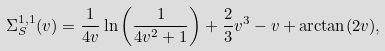Convert formula to latex. <formula><loc_0><loc_0><loc_500><loc_500>\Sigma _ { S } ^ { 1 , 1 } ( v ) = \frac { 1 } { 4 v } \ln \left ( \frac { 1 } { 4 v ^ { 2 } + 1 } \right ) + \frac { 2 } { 3 } v ^ { 3 } - v + \arctan ( 2 v ) ,</formula> 